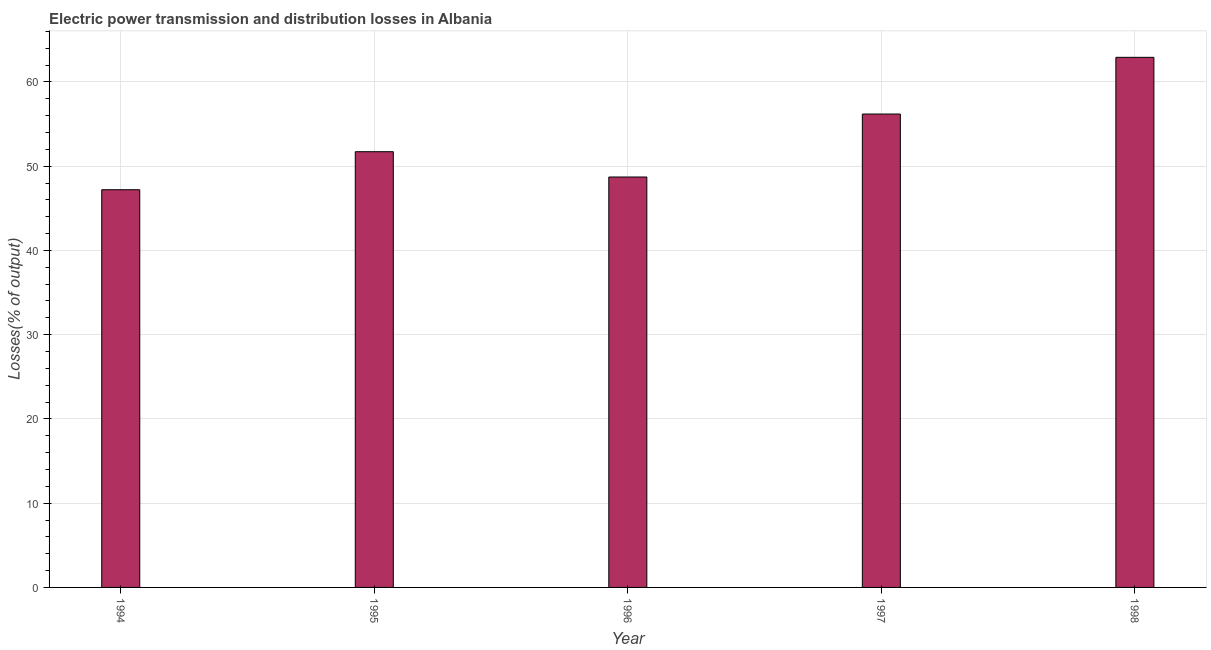Does the graph contain any zero values?
Your answer should be compact. No. Does the graph contain grids?
Ensure brevity in your answer.  Yes. What is the title of the graph?
Make the answer very short. Electric power transmission and distribution losses in Albania. What is the label or title of the Y-axis?
Provide a succinct answer. Losses(% of output). What is the electric power transmission and distribution losses in 1998?
Provide a succinct answer. 62.92. Across all years, what is the maximum electric power transmission and distribution losses?
Provide a succinct answer. 62.92. Across all years, what is the minimum electric power transmission and distribution losses?
Your response must be concise. 47.21. In which year was the electric power transmission and distribution losses maximum?
Make the answer very short. 1998. What is the sum of the electric power transmission and distribution losses?
Your answer should be very brief. 266.76. What is the difference between the electric power transmission and distribution losses in 1994 and 1998?
Offer a very short reply. -15.72. What is the average electric power transmission and distribution losses per year?
Offer a terse response. 53.35. What is the median electric power transmission and distribution losses?
Ensure brevity in your answer.  51.72. In how many years, is the electric power transmission and distribution losses greater than 26 %?
Give a very brief answer. 5. Do a majority of the years between 1998 and 1994 (inclusive) have electric power transmission and distribution losses greater than 26 %?
Provide a succinct answer. Yes. What is the ratio of the electric power transmission and distribution losses in 1995 to that in 1998?
Keep it short and to the point. 0.82. Is the electric power transmission and distribution losses in 1994 less than that in 1996?
Your answer should be compact. Yes. What is the difference between the highest and the second highest electric power transmission and distribution losses?
Keep it short and to the point. 6.73. What is the difference between the highest and the lowest electric power transmission and distribution losses?
Offer a very short reply. 15.72. In how many years, is the electric power transmission and distribution losses greater than the average electric power transmission and distribution losses taken over all years?
Make the answer very short. 2. How many years are there in the graph?
Offer a very short reply. 5. What is the difference between two consecutive major ticks on the Y-axis?
Ensure brevity in your answer.  10. What is the Losses(% of output) in 1994?
Ensure brevity in your answer.  47.21. What is the Losses(% of output) in 1995?
Give a very brief answer. 51.72. What is the Losses(% of output) in 1996?
Your answer should be compact. 48.72. What is the Losses(% of output) of 1997?
Your response must be concise. 56.19. What is the Losses(% of output) in 1998?
Ensure brevity in your answer.  62.92. What is the difference between the Losses(% of output) in 1994 and 1995?
Offer a terse response. -4.51. What is the difference between the Losses(% of output) in 1994 and 1996?
Offer a very short reply. -1.51. What is the difference between the Losses(% of output) in 1994 and 1997?
Keep it short and to the point. -8.98. What is the difference between the Losses(% of output) in 1994 and 1998?
Provide a succinct answer. -15.72. What is the difference between the Losses(% of output) in 1995 and 1996?
Your response must be concise. 3. What is the difference between the Losses(% of output) in 1995 and 1997?
Provide a succinct answer. -4.47. What is the difference between the Losses(% of output) in 1995 and 1998?
Provide a short and direct response. -11.2. What is the difference between the Losses(% of output) in 1996 and 1997?
Ensure brevity in your answer.  -7.47. What is the difference between the Losses(% of output) in 1996 and 1998?
Your response must be concise. -14.21. What is the difference between the Losses(% of output) in 1997 and 1998?
Make the answer very short. -6.73. What is the ratio of the Losses(% of output) in 1994 to that in 1995?
Keep it short and to the point. 0.91. What is the ratio of the Losses(% of output) in 1994 to that in 1996?
Make the answer very short. 0.97. What is the ratio of the Losses(% of output) in 1994 to that in 1997?
Give a very brief answer. 0.84. What is the ratio of the Losses(% of output) in 1995 to that in 1996?
Make the answer very short. 1.06. What is the ratio of the Losses(% of output) in 1995 to that in 1997?
Ensure brevity in your answer.  0.92. What is the ratio of the Losses(% of output) in 1995 to that in 1998?
Provide a short and direct response. 0.82. What is the ratio of the Losses(% of output) in 1996 to that in 1997?
Offer a very short reply. 0.87. What is the ratio of the Losses(% of output) in 1996 to that in 1998?
Your answer should be very brief. 0.77. What is the ratio of the Losses(% of output) in 1997 to that in 1998?
Offer a very short reply. 0.89. 